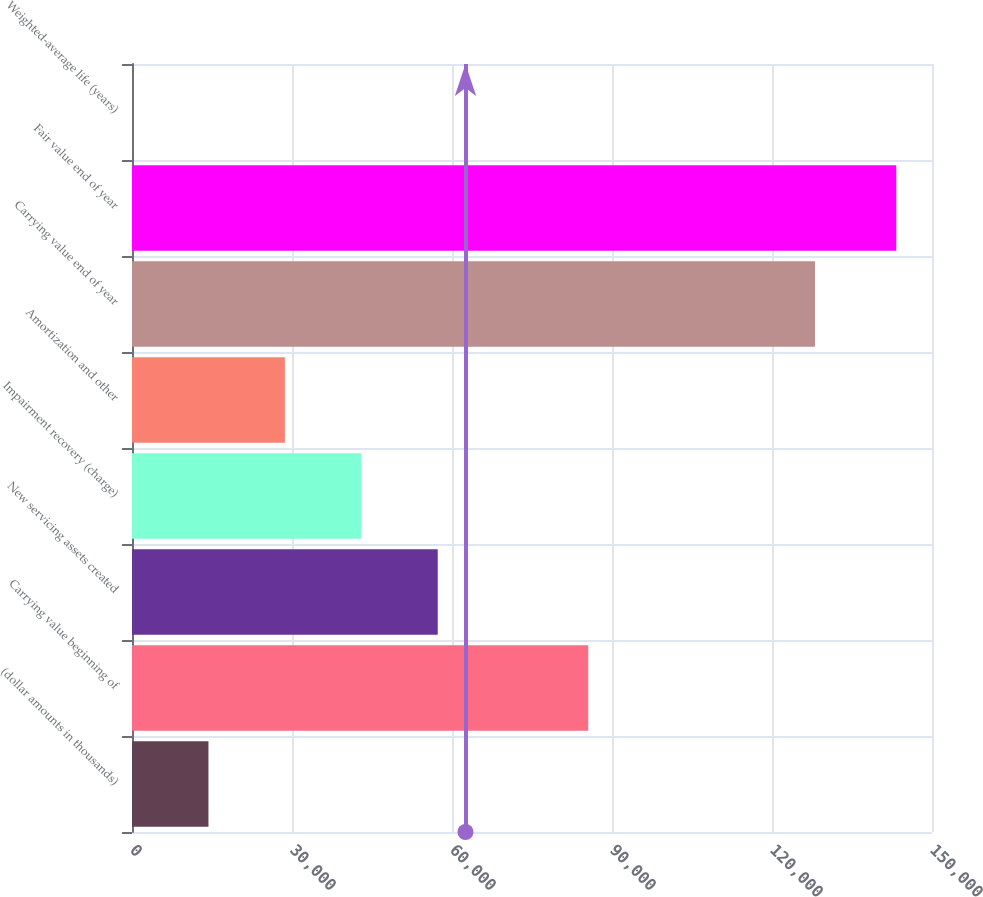Convert chart. <chart><loc_0><loc_0><loc_500><loc_500><bar_chart><fcel>(dollar amounts in thousands)<fcel>Carrying value beginning of<fcel>New servicing assets created<fcel>Impairment recovery (charge)<fcel>Amortization and other<fcel>Carrying value end of year<fcel>Fair value end of year<fcel>Weighted-average life (years)<nl><fcel>14336.5<fcel>85545<fcel>57325.7<fcel>42996<fcel>28666.2<fcel>128064<fcel>143304<fcel>6.8<nl></chart> 